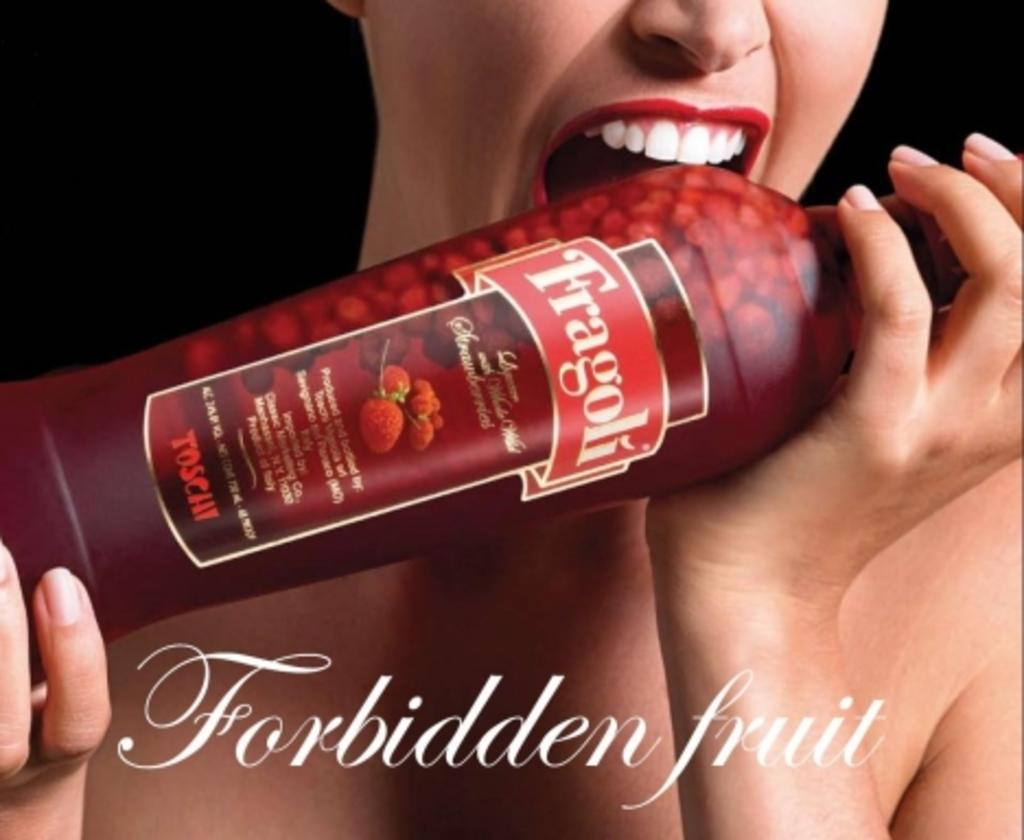Who is present in the image? There is a woman in the image. What is the woman holding in the image? The woman is holding a red-colored bottle. What flavor is the bottle? The bottle has a strawberry flavor. What is written on the bottle? The word "frigoli" is written on the bottle. How is the woman interacting with the bottle? The bottle is near the woman's mouth. Is there a sink visible in the image? No, there is no sink present in the image. Can you see any blood on the woman's hands in the image? No, there is no blood visible on the woman's hands in the image. 